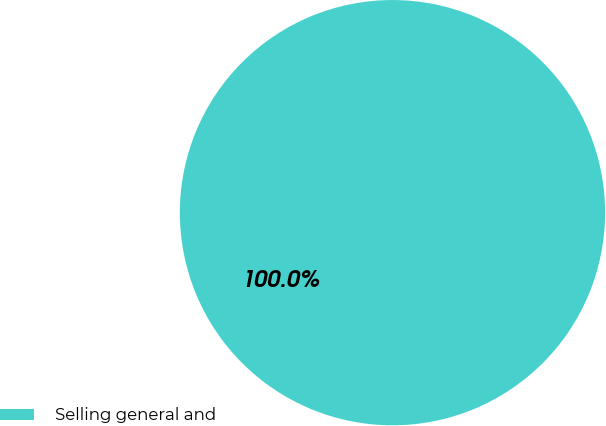<chart> <loc_0><loc_0><loc_500><loc_500><pie_chart><fcel>Selling general and<nl><fcel>100.0%<nl></chart> 